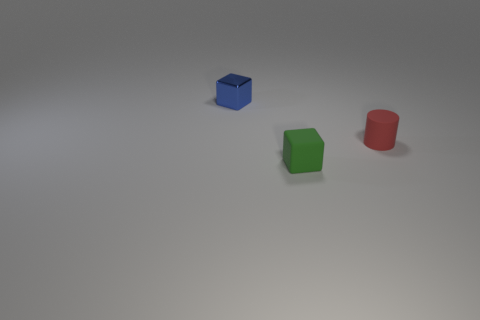Are there any cylinders that have the same size as the blue shiny block?
Your response must be concise. Yes. There is a thing that is right of the green block; is it the same color as the tiny cube in front of the red cylinder?
Your answer should be very brief. No. What number of other things are there of the same shape as the tiny blue metal thing?
Your response must be concise. 1. There is a small object that is in front of the red matte cylinder; what shape is it?
Provide a succinct answer. Cube. There is a small green object; does it have the same shape as the tiny object that is behind the red rubber cylinder?
Your answer should be very brief. Yes. How big is the thing that is both behind the tiny green block and on the left side of the small cylinder?
Your answer should be compact. Small. There is a thing that is both right of the tiny shiny block and left of the tiny red object; what color is it?
Offer a terse response. Green. Is there any other thing that has the same material as the tiny blue thing?
Offer a very short reply. No. Is the number of red matte things that are in front of the green thing less than the number of tiny rubber objects in front of the red thing?
Ensure brevity in your answer.  Yes. What is the shape of the blue object?
Offer a terse response. Cube. 